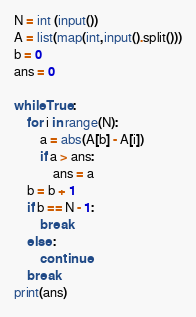<code> <loc_0><loc_0><loc_500><loc_500><_Python_>N = int (input())
A = list(map(int,input().split()))
b = 0
ans = 0

while True:
    for i in range(N):
        a = abs(A[b] - A[i])
        if a > ans:
            ans = a
    b = b + 1
    if b == N - 1:
        break
    else :
        continue
    break      
print(ans)</code> 